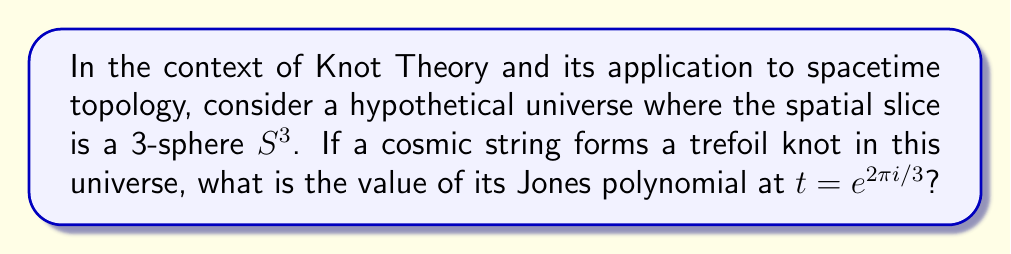Could you help me with this problem? Let's approach this step-by-step:

1) The trefoil knot is one of the simplest non-trivial knots. Its Jones polynomial is given by:

   $$V(t) = t^{-1} + t^{-3} - t^{-4}$$

2) We need to evaluate this polynomial at $t = e^{2\pi i/3}$. Let's substitute this value:

   $$V(e^{2\pi i/3}) = (e^{2\pi i/3})^{-1} + (e^{2\pi i/3})^{-3} - (e^{2\pi i/3})^{-4}$$

3) Simplify the exponents:
   
   $$V(e^{2\pi i/3}) = e^{-2\pi i/3} + e^{-2\pi i} - e^{-8\pi i/3}$$

4) Recall Euler's formula: $e^{ix} = \cos x + i \sin x$

5) Apply this to each term:

   $$V(e^{2\pi i/3}) = (\cos(-2\pi/3) + i\sin(-2\pi/3)) + (\cos(-2\pi) + i\sin(-2\pi)) - (\cos(-8\pi/3) + i\sin(-8\pi/3))$$

6) Simplify:
   - $\cos(-2\pi/3) = -1/2$, $\sin(-2\pi/3) = -\sqrt{3}/2$
   - $\cos(-2\pi) = 1$, $\sin(-2\pi) = 0$
   - $\cos(-8\pi/3) = -1/2$, $\sin(-8\pi/3) = \sqrt{3}/2$

7) Substitute these values:

   $$V(e^{2\pi i/3}) = (-1/2 - i\sqrt{3}/2) + 1 - (-1/2 + i\sqrt{3}/2)$$

8) Simplify:

   $$V(e^{2\pi i/3}) = -1/2 - i\sqrt{3}/2 + 1 + 1/2 - i\sqrt{3}/2 = 1 - i\sqrt{3}$$

This complex number represents a point on the complex plane that corresponds to a specific configuration of the trefoil knot in the 3-sphere spatial slice of our hypothetical universe.
Answer: $1 - i\sqrt{3}$ 